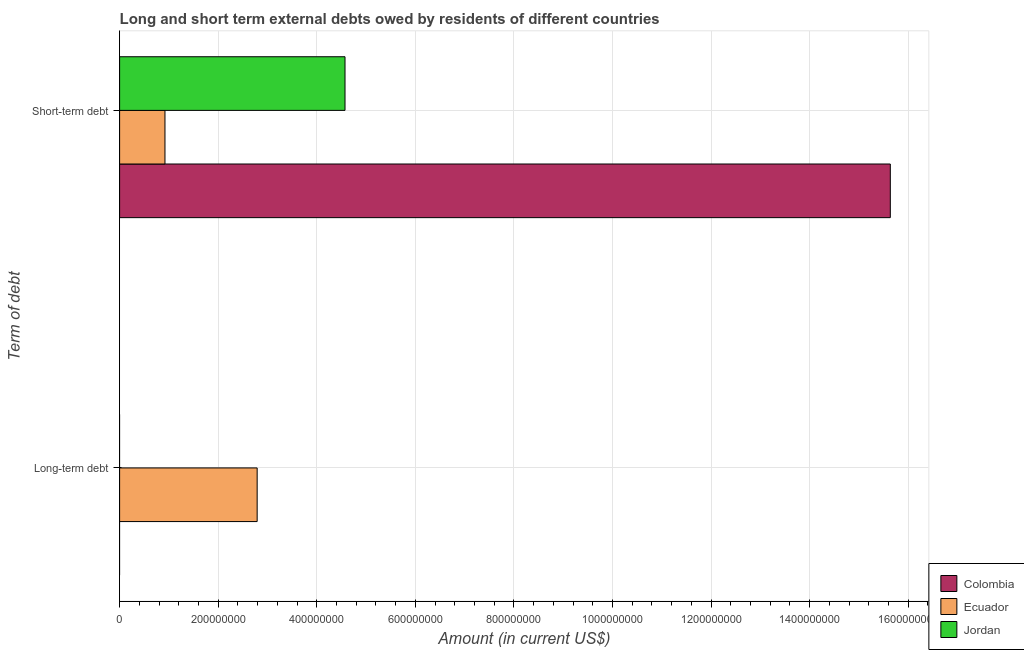How many different coloured bars are there?
Keep it short and to the point. 3. Are the number of bars per tick equal to the number of legend labels?
Keep it short and to the point. No. How many bars are there on the 1st tick from the top?
Make the answer very short. 3. What is the label of the 1st group of bars from the top?
Provide a short and direct response. Short-term debt. What is the short-term debts owed by residents in Ecuador?
Your answer should be compact. 9.20e+07. Across all countries, what is the maximum short-term debts owed by residents?
Give a very brief answer. 1.56e+09. Across all countries, what is the minimum short-term debts owed by residents?
Provide a short and direct response. 9.20e+07. What is the total short-term debts owed by residents in the graph?
Ensure brevity in your answer.  2.11e+09. What is the difference between the short-term debts owed by residents in Ecuador and that in Colombia?
Ensure brevity in your answer.  -1.47e+09. What is the difference between the long-term debts owed by residents in Jordan and the short-term debts owed by residents in Ecuador?
Your answer should be very brief. -9.20e+07. What is the average short-term debts owed by residents per country?
Offer a terse response. 7.04e+08. What is the difference between the long-term debts owed by residents and short-term debts owed by residents in Ecuador?
Your answer should be very brief. 1.87e+08. What is the ratio of the short-term debts owed by residents in Ecuador to that in Colombia?
Keep it short and to the point. 0.06. Is the short-term debts owed by residents in Ecuador less than that in Colombia?
Provide a short and direct response. Yes. In how many countries, is the long-term debts owed by residents greater than the average long-term debts owed by residents taken over all countries?
Provide a succinct answer. 1. Does the graph contain any zero values?
Your answer should be very brief. Yes. Where does the legend appear in the graph?
Offer a very short reply. Bottom right. How many legend labels are there?
Ensure brevity in your answer.  3. How are the legend labels stacked?
Provide a short and direct response. Vertical. What is the title of the graph?
Your response must be concise. Long and short term external debts owed by residents of different countries. What is the label or title of the X-axis?
Ensure brevity in your answer.  Amount (in current US$). What is the label or title of the Y-axis?
Ensure brevity in your answer.  Term of debt. What is the Amount (in current US$) in Ecuador in Long-term debt?
Keep it short and to the point. 2.79e+08. What is the Amount (in current US$) of Colombia in Short-term debt?
Offer a very short reply. 1.56e+09. What is the Amount (in current US$) of Ecuador in Short-term debt?
Offer a very short reply. 9.20e+07. What is the Amount (in current US$) in Jordan in Short-term debt?
Make the answer very short. 4.57e+08. Across all Term of debt, what is the maximum Amount (in current US$) of Colombia?
Offer a very short reply. 1.56e+09. Across all Term of debt, what is the maximum Amount (in current US$) of Ecuador?
Keep it short and to the point. 2.79e+08. Across all Term of debt, what is the maximum Amount (in current US$) of Jordan?
Your answer should be compact. 4.57e+08. Across all Term of debt, what is the minimum Amount (in current US$) in Colombia?
Ensure brevity in your answer.  0. Across all Term of debt, what is the minimum Amount (in current US$) in Ecuador?
Your answer should be very brief. 9.20e+07. Across all Term of debt, what is the minimum Amount (in current US$) in Jordan?
Your response must be concise. 0. What is the total Amount (in current US$) in Colombia in the graph?
Provide a succinct answer. 1.56e+09. What is the total Amount (in current US$) of Ecuador in the graph?
Provide a short and direct response. 3.71e+08. What is the total Amount (in current US$) in Jordan in the graph?
Offer a terse response. 4.57e+08. What is the difference between the Amount (in current US$) in Ecuador in Long-term debt and that in Short-term debt?
Provide a succinct answer. 1.87e+08. What is the difference between the Amount (in current US$) in Ecuador in Long-term debt and the Amount (in current US$) in Jordan in Short-term debt?
Offer a very short reply. -1.78e+08. What is the average Amount (in current US$) in Colombia per Term of debt?
Offer a very short reply. 7.82e+08. What is the average Amount (in current US$) in Ecuador per Term of debt?
Keep it short and to the point. 1.86e+08. What is the average Amount (in current US$) in Jordan per Term of debt?
Ensure brevity in your answer.  2.29e+08. What is the difference between the Amount (in current US$) in Colombia and Amount (in current US$) in Ecuador in Short-term debt?
Ensure brevity in your answer.  1.47e+09. What is the difference between the Amount (in current US$) of Colombia and Amount (in current US$) of Jordan in Short-term debt?
Make the answer very short. 1.11e+09. What is the difference between the Amount (in current US$) in Ecuador and Amount (in current US$) in Jordan in Short-term debt?
Offer a terse response. -3.65e+08. What is the ratio of the Amount (in current US$) of Ecuador in Long-term debt to that in Short-term debt?
Provide a succinct answer. 3.03. What is the difference between the highest and the second highest Amount (in current US$) in Ecuador?
Your response must be concise. 1.87e+08. What is the difference between the highest and the lowest Amount (in current US$) in Colombia?
Provide a succinct answer. 1.56e+09. What is the difference between the highest and the lowest Amount (in current US$) in Ecuador?
Offer a very short reply. 1.87e+08. What is the difference between the highest and the lowest Amount (in current US$) in Jordan?
Give a very brief answer. 4.57e+08. 